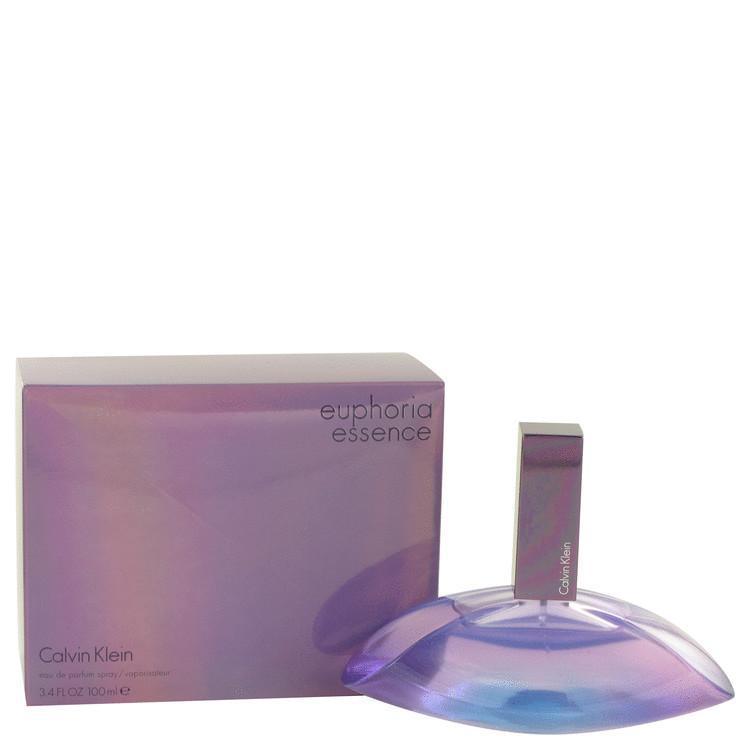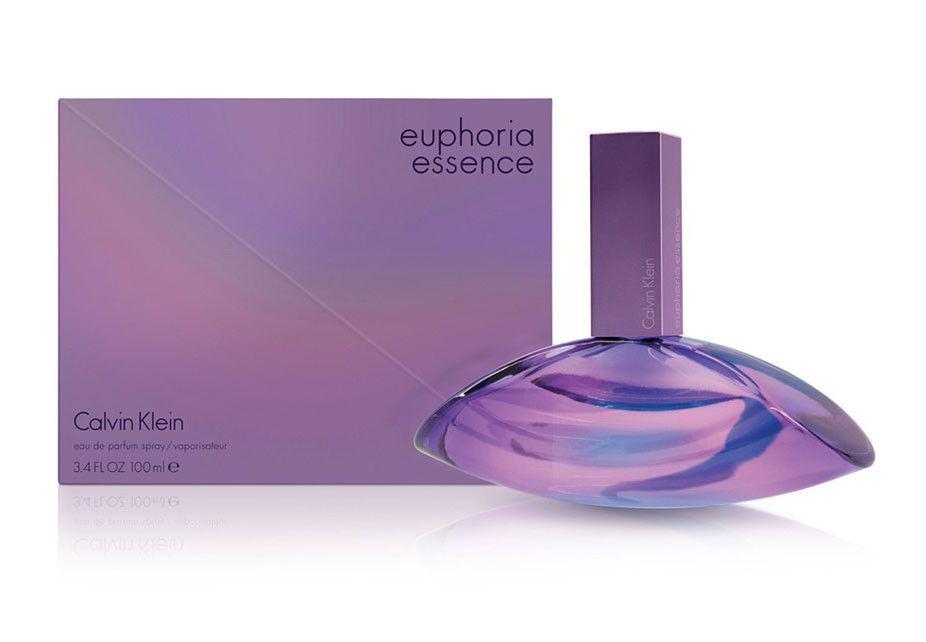The first image is the image on the left, the second image is the image on the right. Given the left and right images, does the statement "The top of the lid of a purple bottle is visible in the image on the left." hold true? Answer yes or no. Yes. 